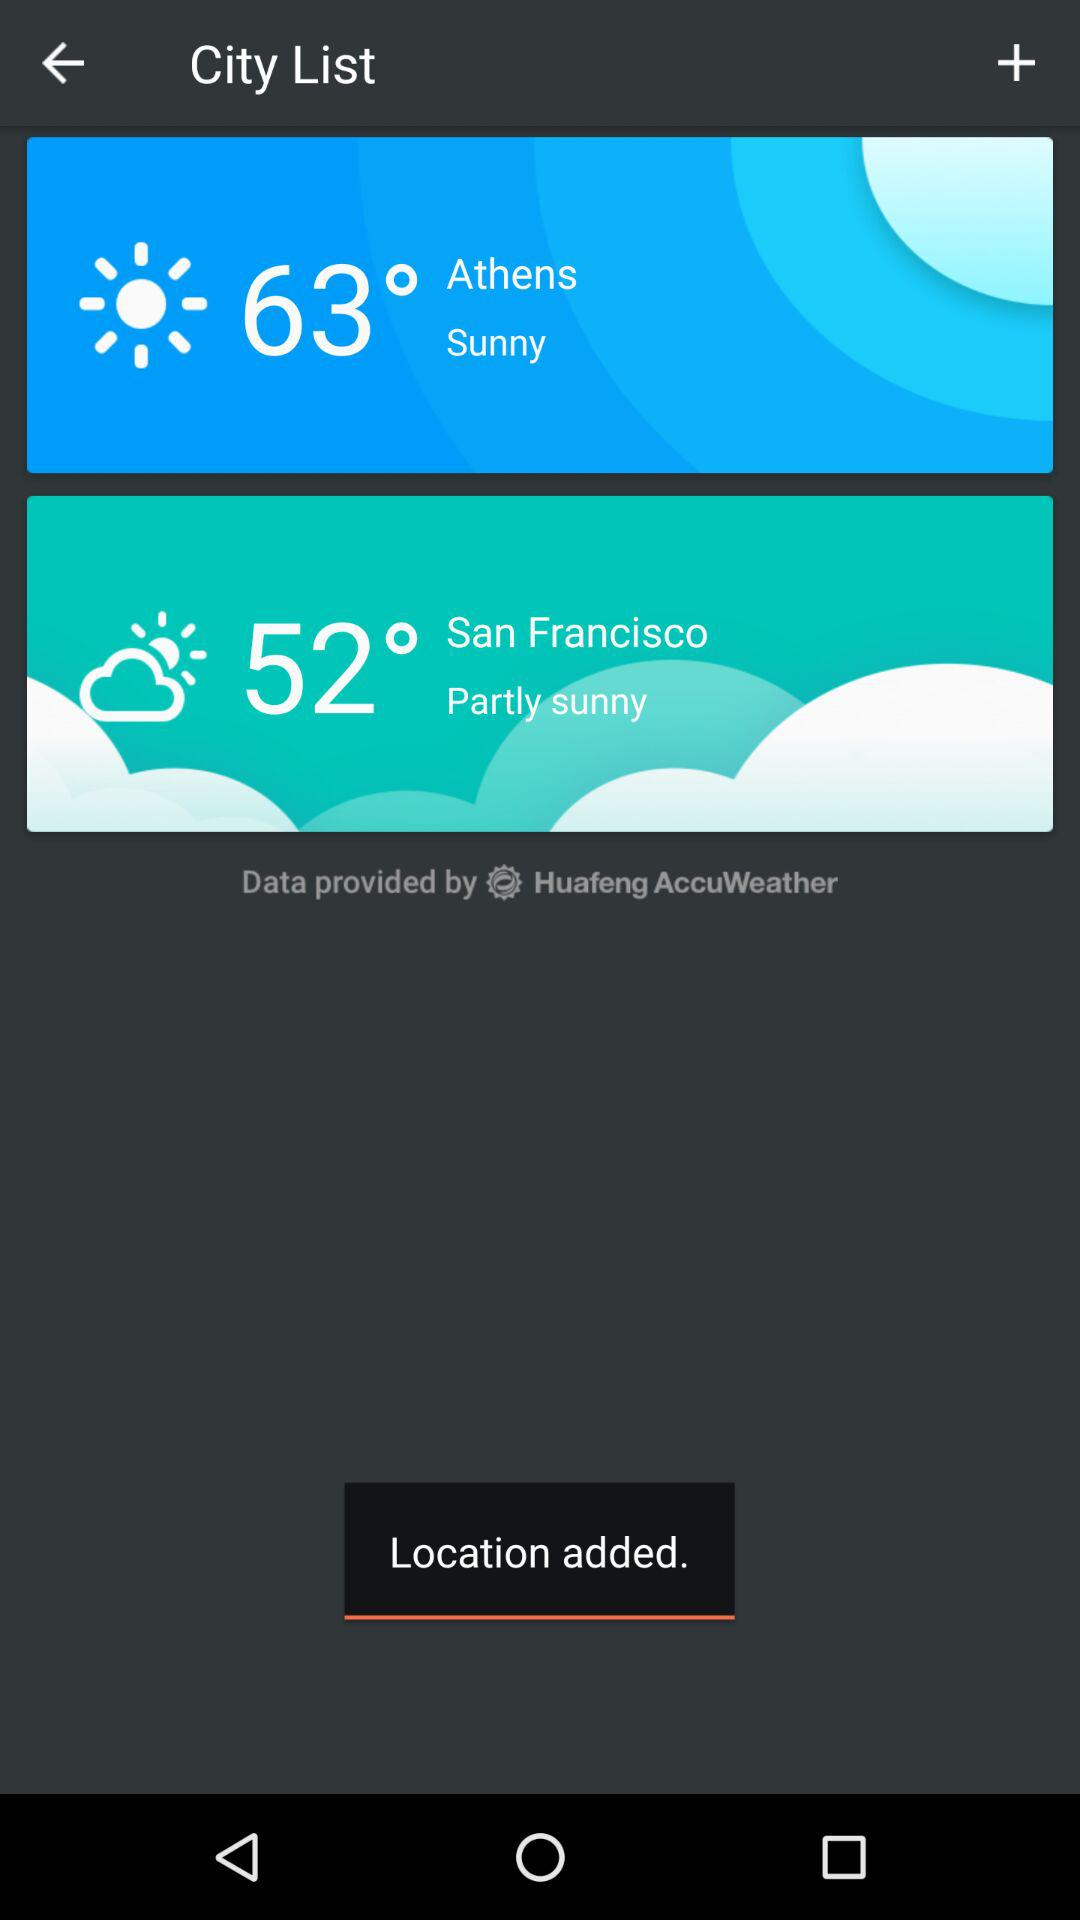How is the weather in San Francisco? The weather in San Francisco is partly sunny. 